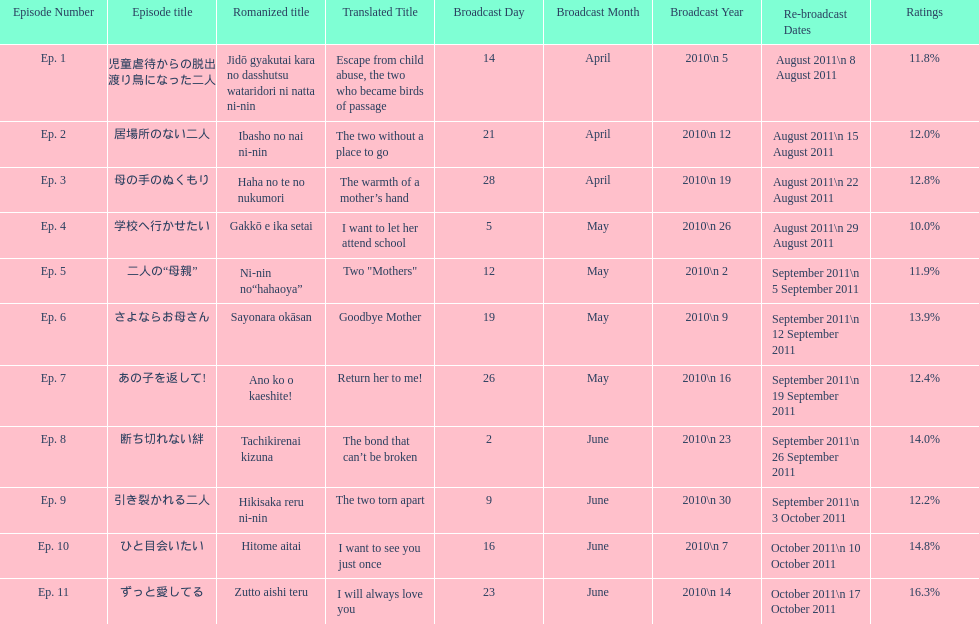Can you parse all the data within this table? {'header': ['Episode Number', 'Episode title', 'Romanized title', 'Translated Title', 'Broadcast Day', 'Broadcast Month', 'Broadcast Year', 'Re-broadcast Dates', 'Ratings'], 'rows': [['Ep. 1', '児童虐待からの脱出 渡り鳥になった二人', 'Jidō gyakutai kara no dasshutsu wataridori ni natta ni-nin', 'Escape from child abuse, the two who became birds of passage', '14', 'April', '2010\\n 5', 'August 2011\\n 8 August 2011', '11.8%'], ['Ep. 2', '居場所のない二人', 'Ibasho no nai ni-nin', 'The two without a place to go', '21', 'April', '2010\\n 12', 'August 2011\\n 15 August 2011', '12.0%'], ['Ep. 3', '母の手のぬくもり', 'Haha no te no nukumori', 'The warmth of a mother’s hand', '28', 'April', '2010\\n 19', 'August 2011\\n 22 August 2011', '12.8%'], ['Ep. 4', '学校へ行かせたい', 'Gakkō e ika setai', 'I want to let her attend school', '5', 'May', '2010\\n 26', 'August 2011\\n 29 August 2011', '10.0%'], ['Ep. 5', '二人の“母親”', 'Ni-nin no“hahaoya”', 'Two "Mothers"', '12', 'May', '2010\\n 2', 'September 2011\\n 5 September 2011', '11.9%'], ['Ep. 6', 'さよならお母さん', 'Sayonara okāsan', 'Goodbye Mother', '19', 'May', '2010\\n 9', 'September 2011\\n 12 September 2011', '13.9%'], ['Ep. 7', 'あの子を返して!', 'Ano ko o kaeshite!', 'Return her to me!', '26', 'May', '2010\\n 16', 'September 2011\\n 19 September 2011', '12.4%'], ['Ep. 8', '断ち切れない絆', 'Tachikirenai kizuna', 'The bond that can’t be broken', '2', 'June', '2010\\n 23', 'September 2011\\n 26 September 2011', '14.0%'], ['Ep. 9', '引き裂かれる二人', 'Hikisaka reru ni-nin', 'The two torn apart', '9', 'June', '2010\\n 30', 'September 2011\\n 3 October 2011', '12.2%'], ['Ep. 10', 'ひと目会いたい', 'Hitome aitai', 'I want to see you just once', '16', 'June', '2010\\n 7', 'October 2011\\n 10 October 2011', '14.8%'], ['Ep. 11', 'ずっと愛してる', 'Zutto aishi teru', 'I will always love you', '23', 'June', '2010\\n 14', 'October 2011\\n 17 October 2011', '16.3%']]} How many episodes had a consecutive rating over 11%? 7. 